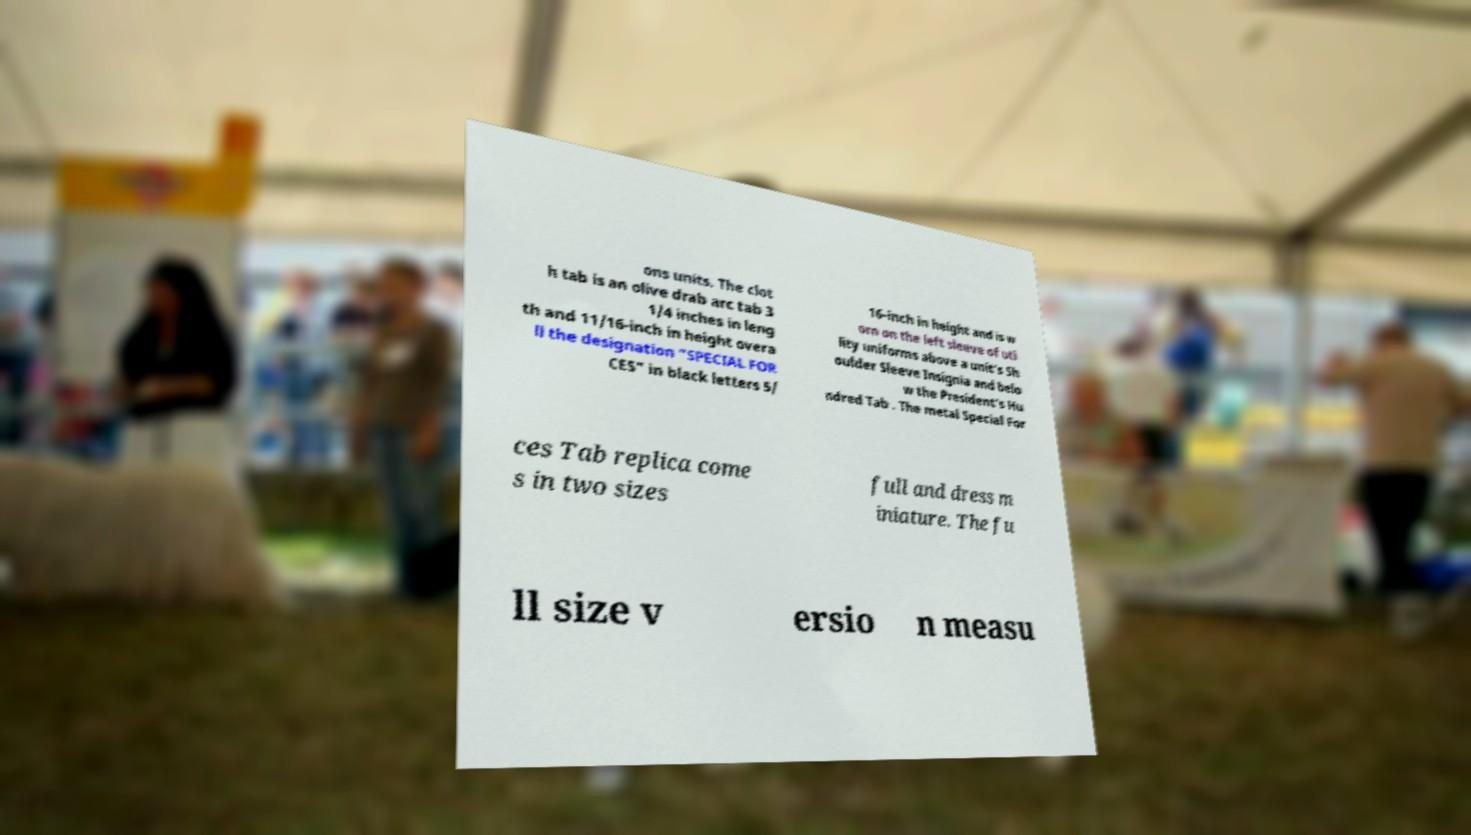There's text embedded in this image that I need extracted. Can you transcribe it verbatim? ons units. The clot h tab is an olive drab arc tab 3 1/4 inches in leng th and 11/16-inch in height overa ll the designation "SPECIAL FOR CES" in black letters 5/ 16-inch in height and is w orn on the left sleeve of uti lity uniforms above a unit's Sh oulder Sleeve Insignia and belo w the President's Hu ndred Tab . The metal Special For ces Tab replica come s in two sizes full and dress m iniature. The fu ll size v ersio n measu 